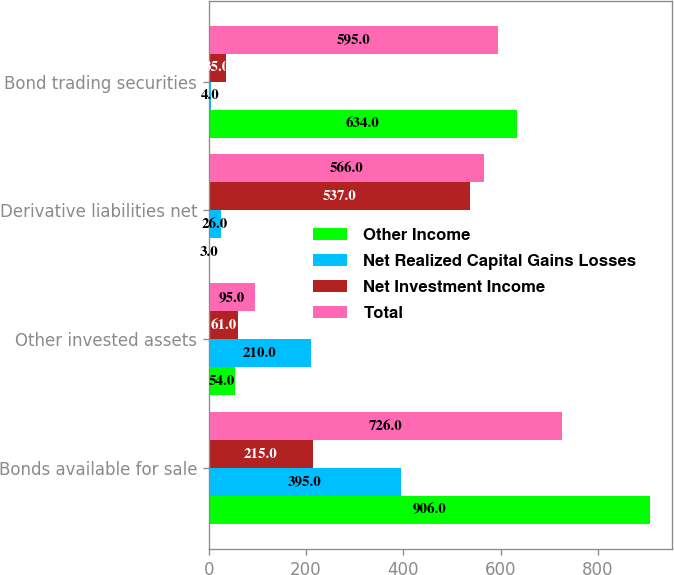Convert chart to OTSL. <chart><loc_0><loc_0><loc_500><loc_500><stacked_bar_chart><ecel><fcel>Bonds available for sale<fcel>Other invested assets<fcel>Derivative liabilities net<fcel>Bond trading securities<nl><fcel>Other Income<fcel>906<fcel>54<fcel>3<fcel>634<nl><fcel>Net Realized Capital Gains Losses<fcel>395<fcel>210<fcel>26<fcel>4<nl><fcel>Net Investment Income<fcel>215<fcel>61<fcel>537<fcel>35<nl><fcel>Total<fcel>726<fcel>95<fcel>566<fcel>595<nl></chart> 